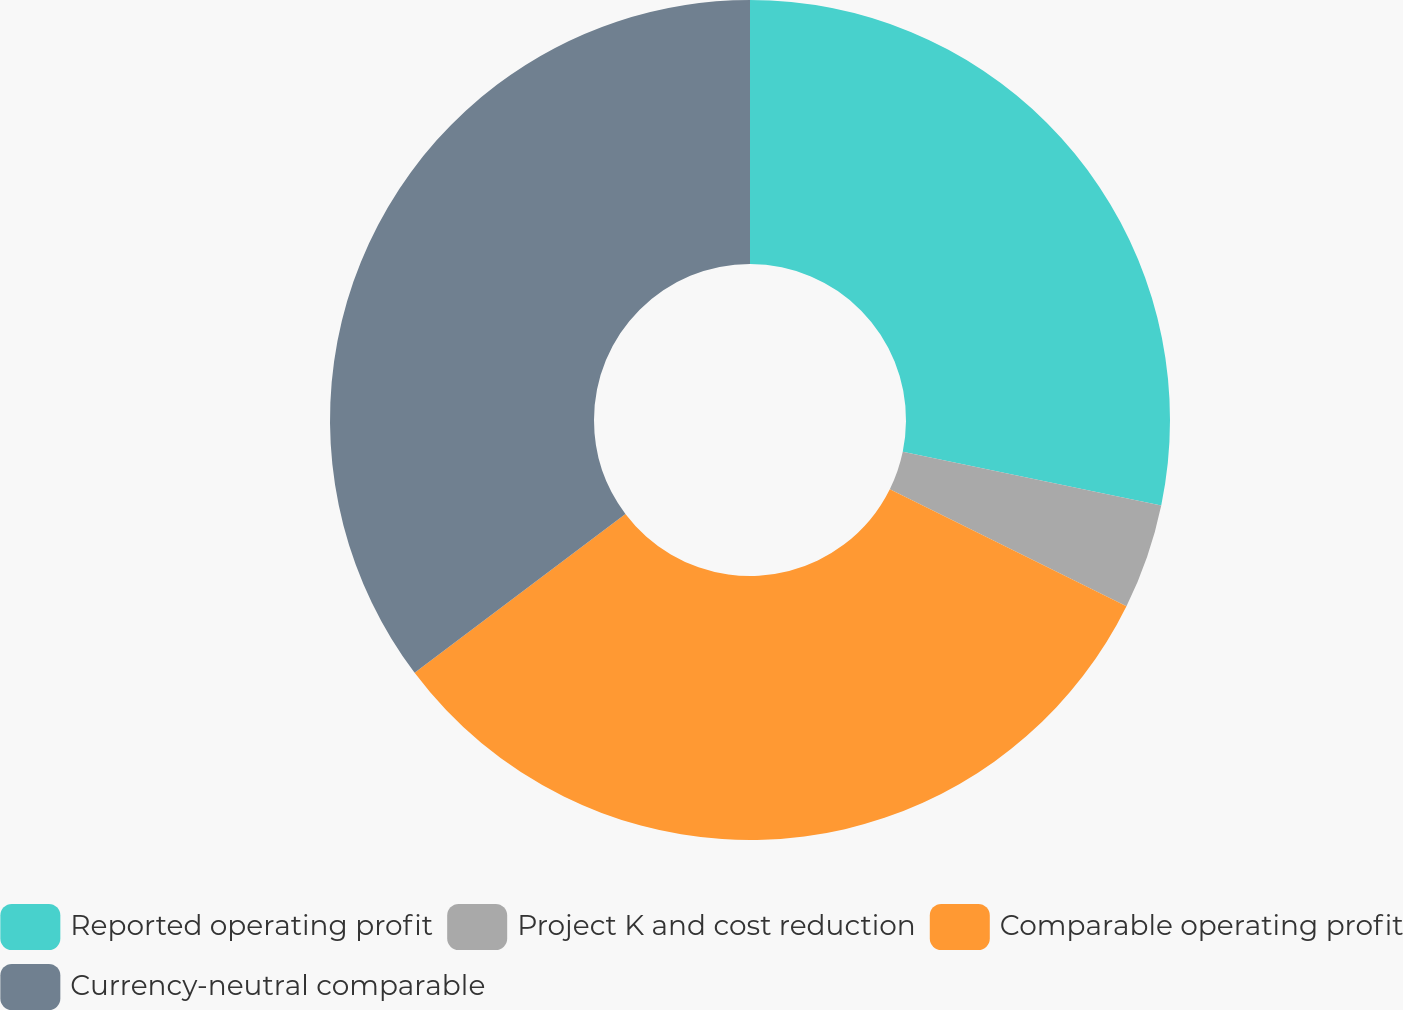Convert chart. <chart><loc_0><loc_0><loc_500><loc_500><pie_chart><fcel>Reported operating profit<fcel>Project K and cost reduction<fcel>Comparable operating profit<fcel>Currency-neutral comparable<nl><fcel>28.26%<fcel>4.05%<fcel>32.41%<fcel>35.28%<nl></chart> 